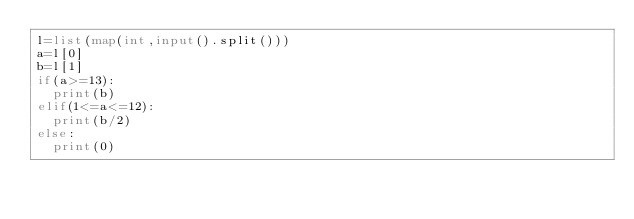Convert code to text. <code><loc_0><loc_0><loc_500><loc_500><_Python_>l=list(map(int,input().split()))
a=l[0]
b=l[1]
if(a>=13):
  print(b)
elif(1<=a<=12):
  print(b/2)
else:
  print(0)</code> 